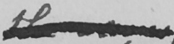Please transcribe the handwritten text in this image. the same 